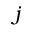<formula> <loc_0><loc_0><loc_500><loc_500>j</formula> 